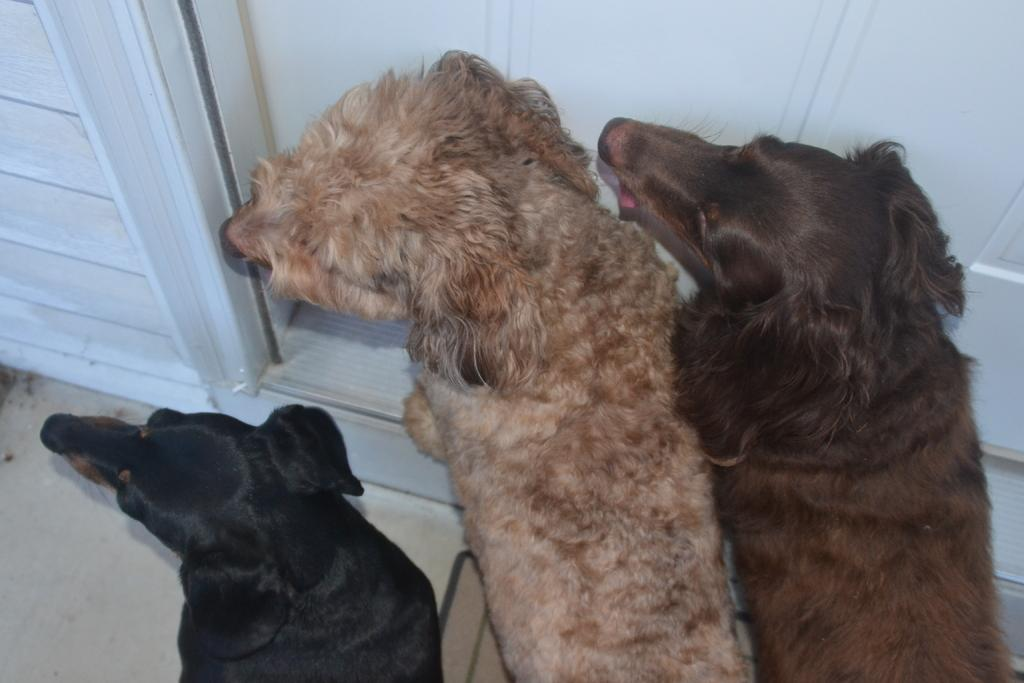How many dogs are in the image? There are three dogs in the image. Where are the dogs located in relation to other objects in the image? The dogs are standing near a door. What type of wall is visible on the left side of the image? There is a wooden wall on the left side of the image. What is at the bottom of the image? There is a mat at the bottom of the image. What opinion do the dogs have about the chalk on the top of the image? There is no chalk present in the image, and the dogs' opinions cannot be determined. What is the dogs' reaction to the top of the image? The dogs are standing near a door, and there is no specific reaction to the top of the image mentioned in the facts. 